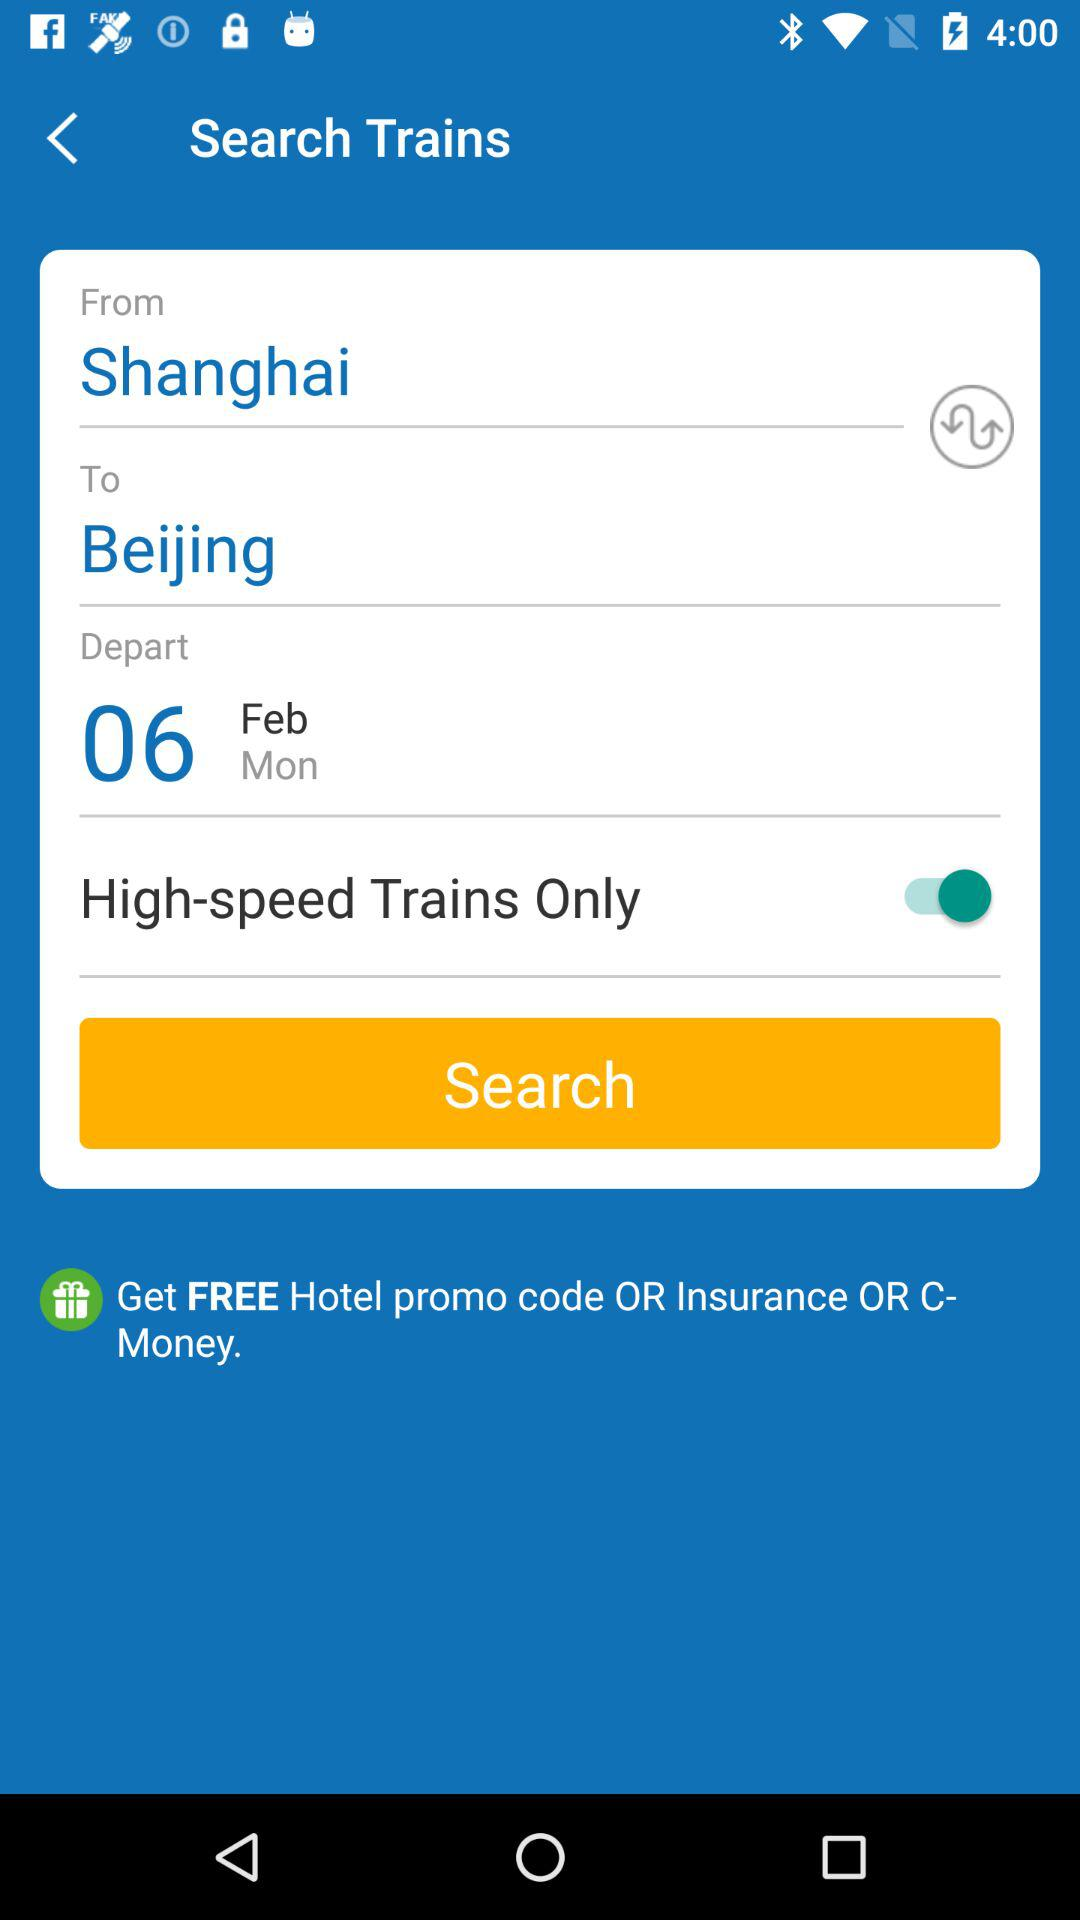What is the departure station? The departure station is "Shanghai". 